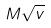<formula> <loc_0><loc_0><loc_500><loc_500>M \sqrt { v }</formula> 